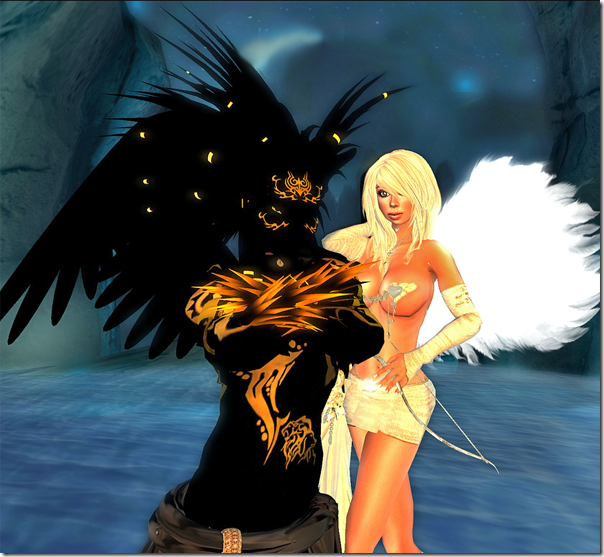What does the icy background setting suggest about the story or setting of these characters? The icy background in the image juxtaposes the fiery and ethereal elements of the characters' attire, suggesting a setting that is both harsh and enchanting, potentially symbolic of a mythical realm. This environment could imply that the characters exist in a world where elemental forces are at play, reflecting themes of endurance, power, and mysticism. The cold, remote setting might also be indicative of isolation or a battle against formidable natural forces, adding layers of narrative complexity about survival or mastery over nature. 